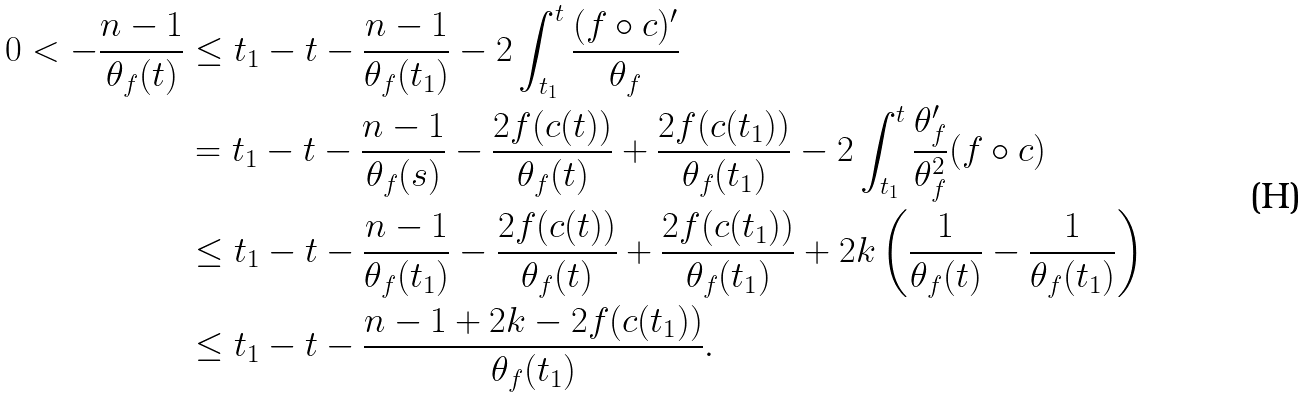Convert formula to latex. <formula><loc_0><loc_0><loc_500><loc_500>0 < - \frac { n - 1 } { \theta _ { f } ( t ) } & \leq t _ { 1 } - t - \frac { n - 1 } { \theta _ { f } ( t _ { 1 } ) } - 2 \int _ { t _ { 1 } } ^ { t } \frac { ( f \circ c ) ^ { \prime } } { \theta _ { f } } \\ & = t _ { 1 } - t - \frac { n - 1 } { \theta _ { f } ( s ) } - \frac { 2 f ( c ( t ) ) } { \theta _ { f } ( t ) } + \frac { 2 f ( c ( t _ { 1 } ) ) } { \theta _ { f } ( t _ { 1 } ) } - 2 \int _ { t _ { 1 } } ^ { t } \frac { \theta _ { f } ^ { \prime } } { \theta _ { f } ^ { 2 } } ( f \circ c ) \\ & \leq t _ { 1 } - t - \frac { n - 1 } { \theta _ { f } ( t _ { 1 } ) } - \frac { 2 f ( c ( t ) ) } { \theta _ { f } ( t ) } + \frac { 2 f ( c ( t _ { 1 } ) ) } { \theta _ { f } ( t _ { 1 } ) } + 2 k \left ( \frac { 1 } { \theta _ { f } ( t ) } - \frac { 1 } { \theta _ { f } ( t _ { 1 } ) } \right ) \\ & \leq t _ { 1 } - t - \frac { n - 1 + 2 k - 2 f ( c ( t _ { 1 } ) ) } { \theta _ { f } ( t _ { 1 } ) } .</formula> 